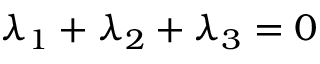<formula> <loc_0><loc_0><loc_500><loc_500>{ \lambda _ { 1 } } + { \lambda _ { 2 } } + { \lambda _ { 3 } } = 0</formula> 